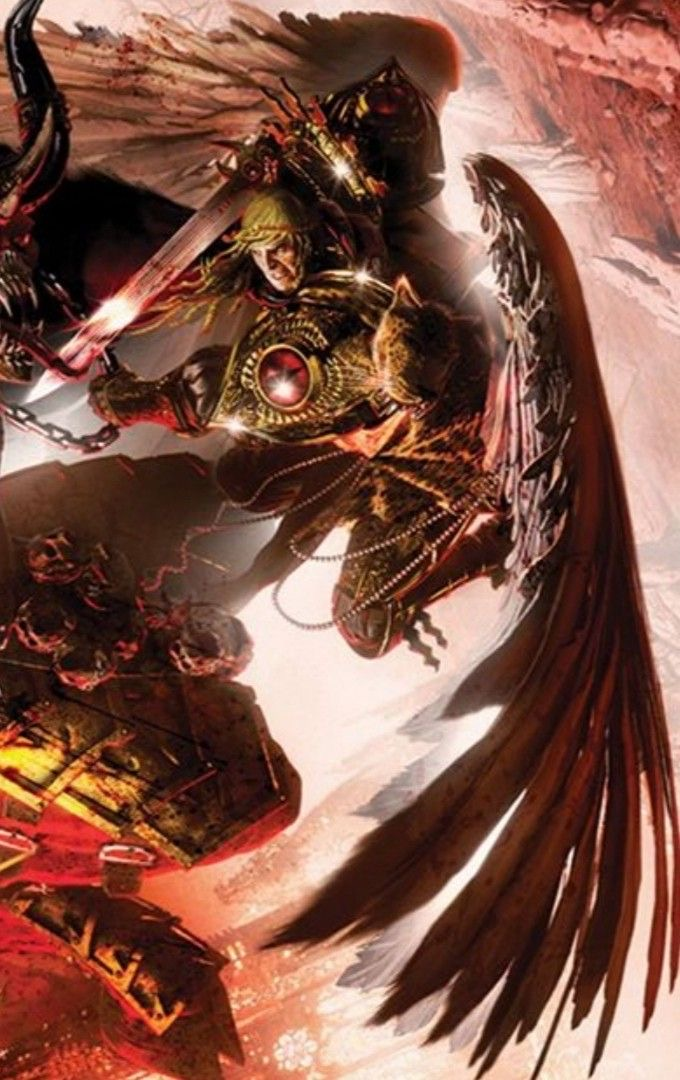describe  The picture shows an angel with a red and black color scheme. He is wearing golden armor and has a red cape. He is also wielding a sword and a shield. The angel is standing in a field of skulls and is surrounded by a number of demons. The angel is fighting the demons and is winning. 